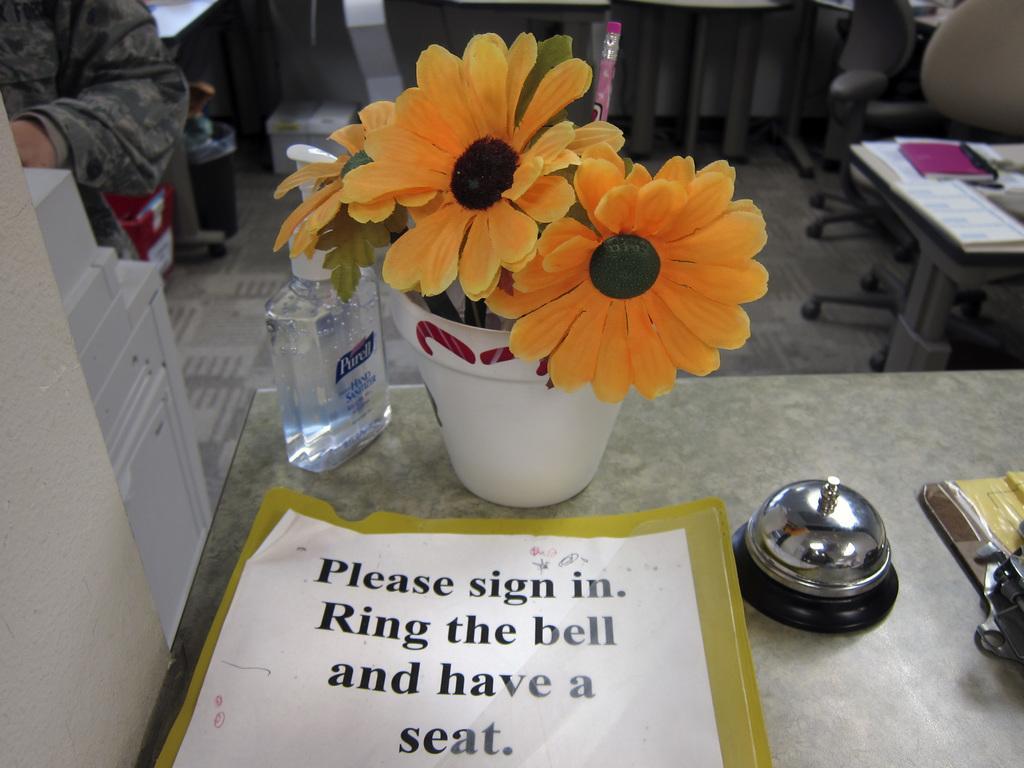Please provide a concise description of this image. On the table there is a flower pot, sanitize bottle, a bell and a exam pad on it. And to the right top corner there is a chair. And to the left top corner there is a man standing. And also there is a printer. 